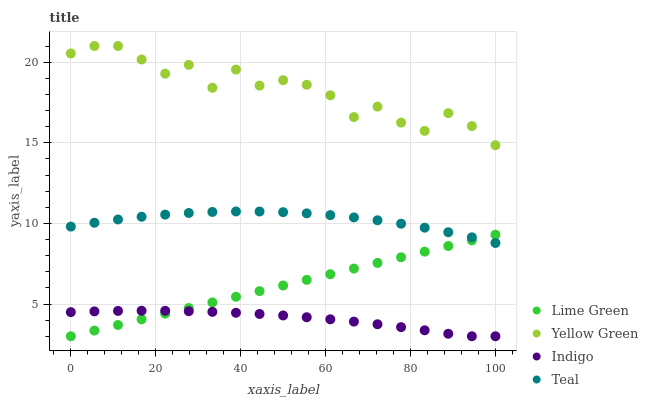Does Indigo have the minimum area under the curve?
Answer yes or no. Yes. Does Yellow Green have the maximum area under the curve?
Answer yes or no. Yes. Does Lime Green have the minimum area under the curve?
Answer yes or no. No. Does Lime Green have the maximum area under the curve?
Answer yes or no. No. Is Lime Green the smoothest?
Answer yes or no. Yes. Is Yellow Green the roughest?
Answer yes or no. Yes. Is Yellow Green the smoothest?
Answer yes or no. No. Is Lime Green the roughest?
Answer yes or no. No. Does Indigo have the lowest value?
Answer yes or no. Yes. Does Yellow Green have the lowest value?
Answer yes or no. No. Does Yellow Green have the highest value?
Answer yes or no. Yes. Does Lime Green have the highest value?
Answer yes or no. No. Is Indigo less than Teal?
Answer yes or no. Yes. Is Yellow Green greater than Teal?
Answer yes or no. Yes. Does Indigo intersect Lime Green?
Answer yes or no. Yes. Is Indigo less than Lime Green?
Answer yes or no. No. Is Indigo greater than Lime Green?
Answer yes or no. No. Does Indigo intersect Teal?
Answer yes or no. No. 